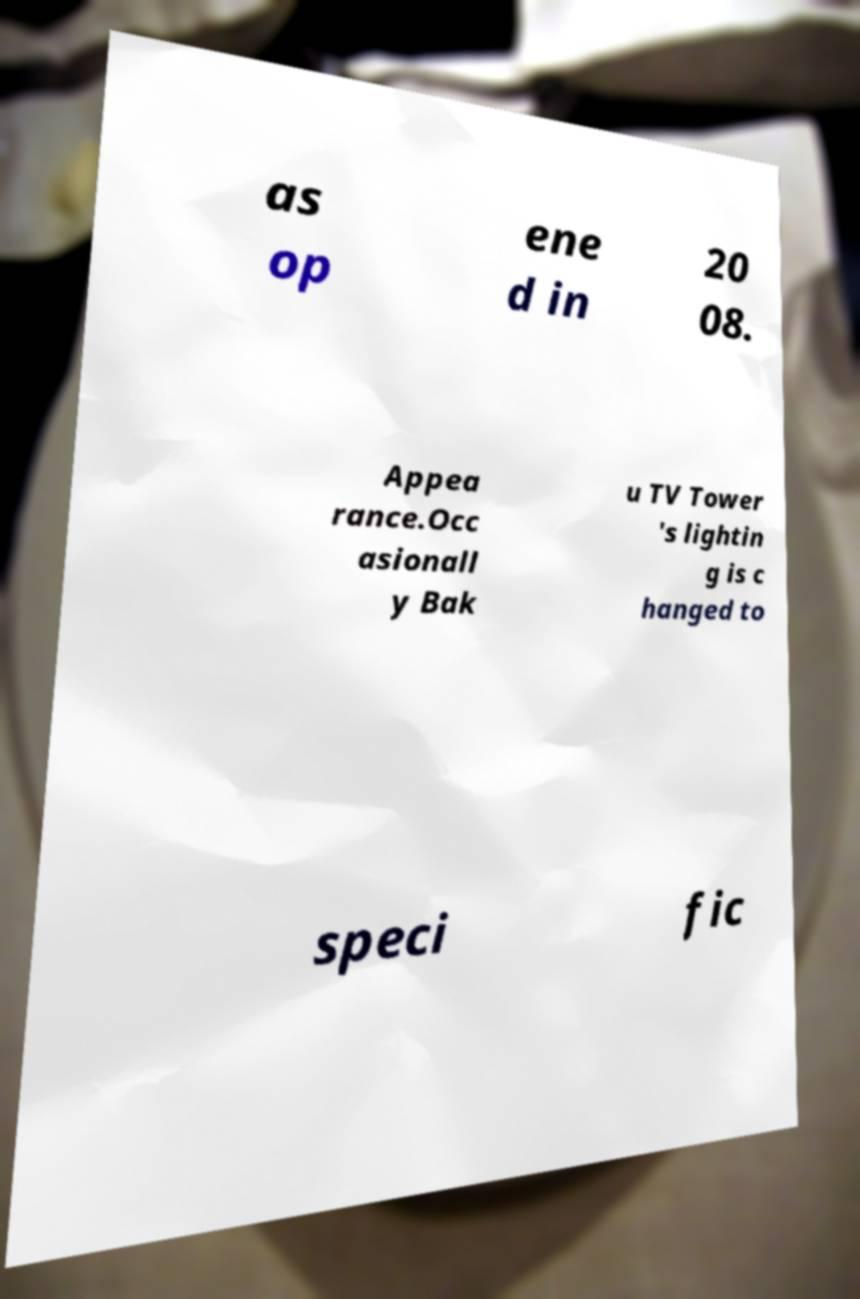Can you read and provide the text displayed in the image?This photo seems to have some interesting text. Can you extract and type it out for me? as op ene d in 20 08. Appea rance.Occ asionall y Bak u TV Tower 's lightin g is c hanged to speci fic 